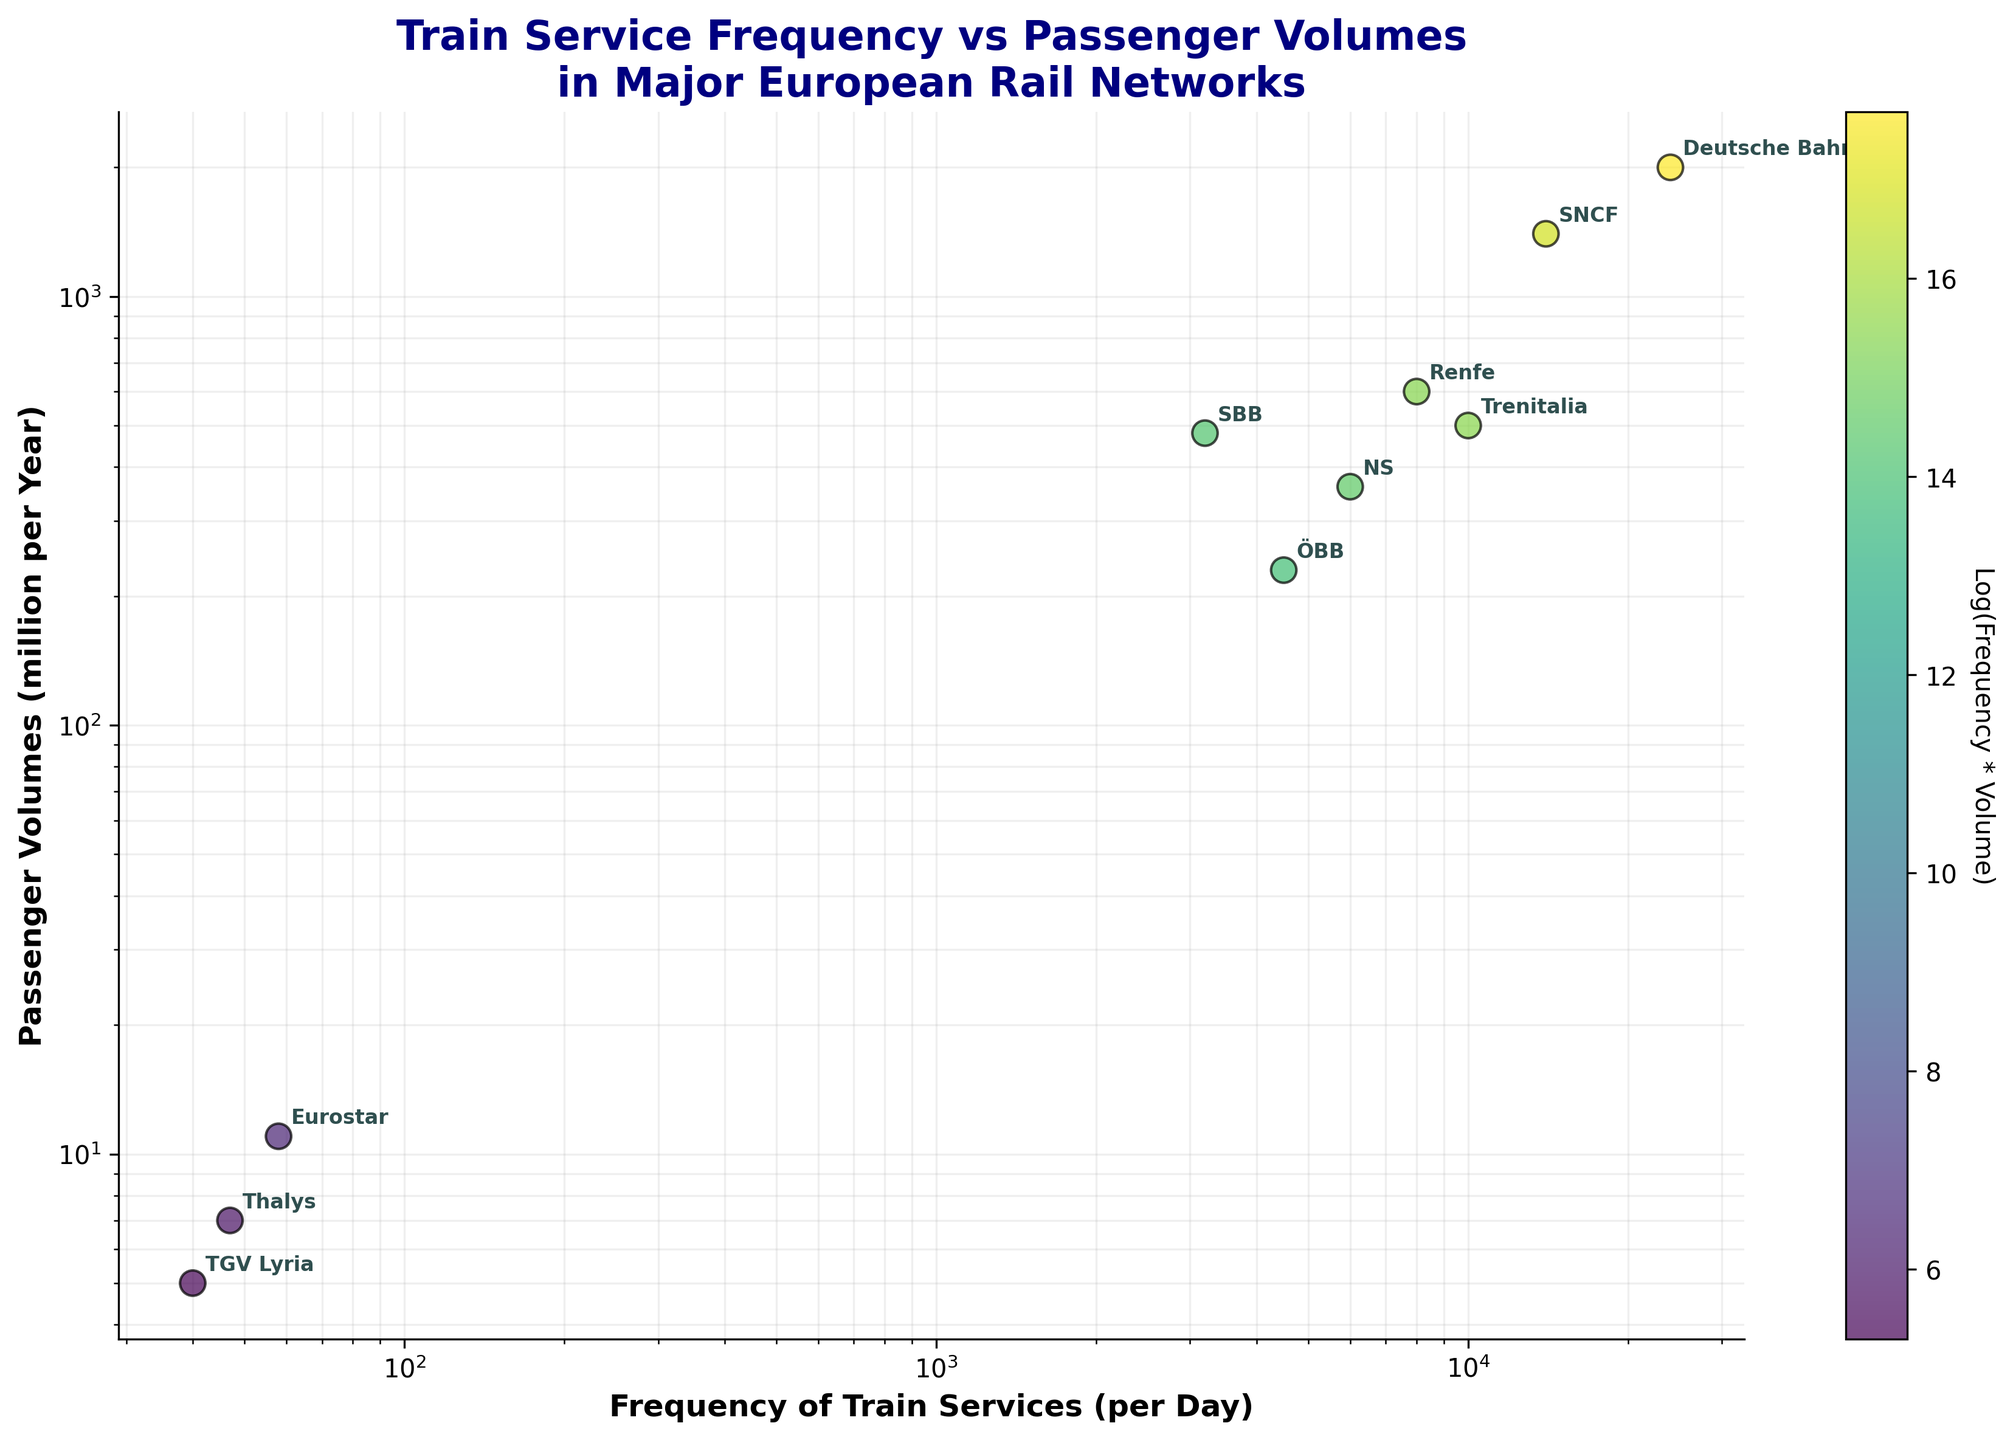What's the title of the chart? The title of the chart is displayed at the top center. It reads "Train Service Frequency vs Passenger Volumes in Major European Rail Networks".
Answer: Train Service Frequency vs Passenger Volumes in Major European Rail Networks How many rail networks are depicted in this chart? Each rail network is represented by a labeled data point. Count the number of unique labels. There are 10 labels.
Answer: 10 Which rail network has the highest frequency of train services per day? Look for the data point with the highest x-axis value which represents the frequency of train services per day. The label for this point is "Deutsche Bahn".
Answer: Deutsche Bahn Which two rail networks have the closest passenger volumes? Compare the y-axis values which represent passenger volumes. The closest passenger volumes are between "Eurostar" (11 million per year) and "Thalys" (7 million per year).
Answer: Eurostar and Thalys What is the approximate range of passenger volumes shown in the chart? Identify the smallest and largest y-axis values, which represent the passenger volumes. The range is from about 5 million to 2000 million per year.
Answer: 5 to 2000 million per year Is the frequency of train services for "Eurostar" higher or lower than for "Thalys"? Compare the x-axis values for "Eurostar" and "Thalys". Eurostar has a higher frequency (58 per day) compared to Thalys (47 per day).
Answer: Higher Which rail network has the lowest product of frequency of train services and passenger volumes, given that the color intensity represents this product? The color intensity indicates the product of frequency and volume. "TGV Lyria" appears to have the lightest color, indicating the lowest product.
Answer: TGV Lyria For which rail network is the product of frequency of train services and passenger volumes close to the average? Calculate or estimate the average of the products and compare it to each network. Look for data points with mid-range color intensity. "Trenitalia" seems to be close to the average because of its mid-tone color.
Answer: Trenitalia What's the approximate difference in passenger volumes between "Renfe" and "SNCF"? Look at the y-axis values for "Renfe" (600 million) and "SNCF" (1400 million). The difference is 1400 - 600 = 800 million per year.
Answer: 800 million per year How does "ÖBB" compare to "SBB" in terms of train service frequency? Compare the x-axis positions for "ÖBB" (4500 per day) and "SBB" (3200 per day). "ÖBB" has a higher train service frequency.
Answer: ÖBB has higher frequency 